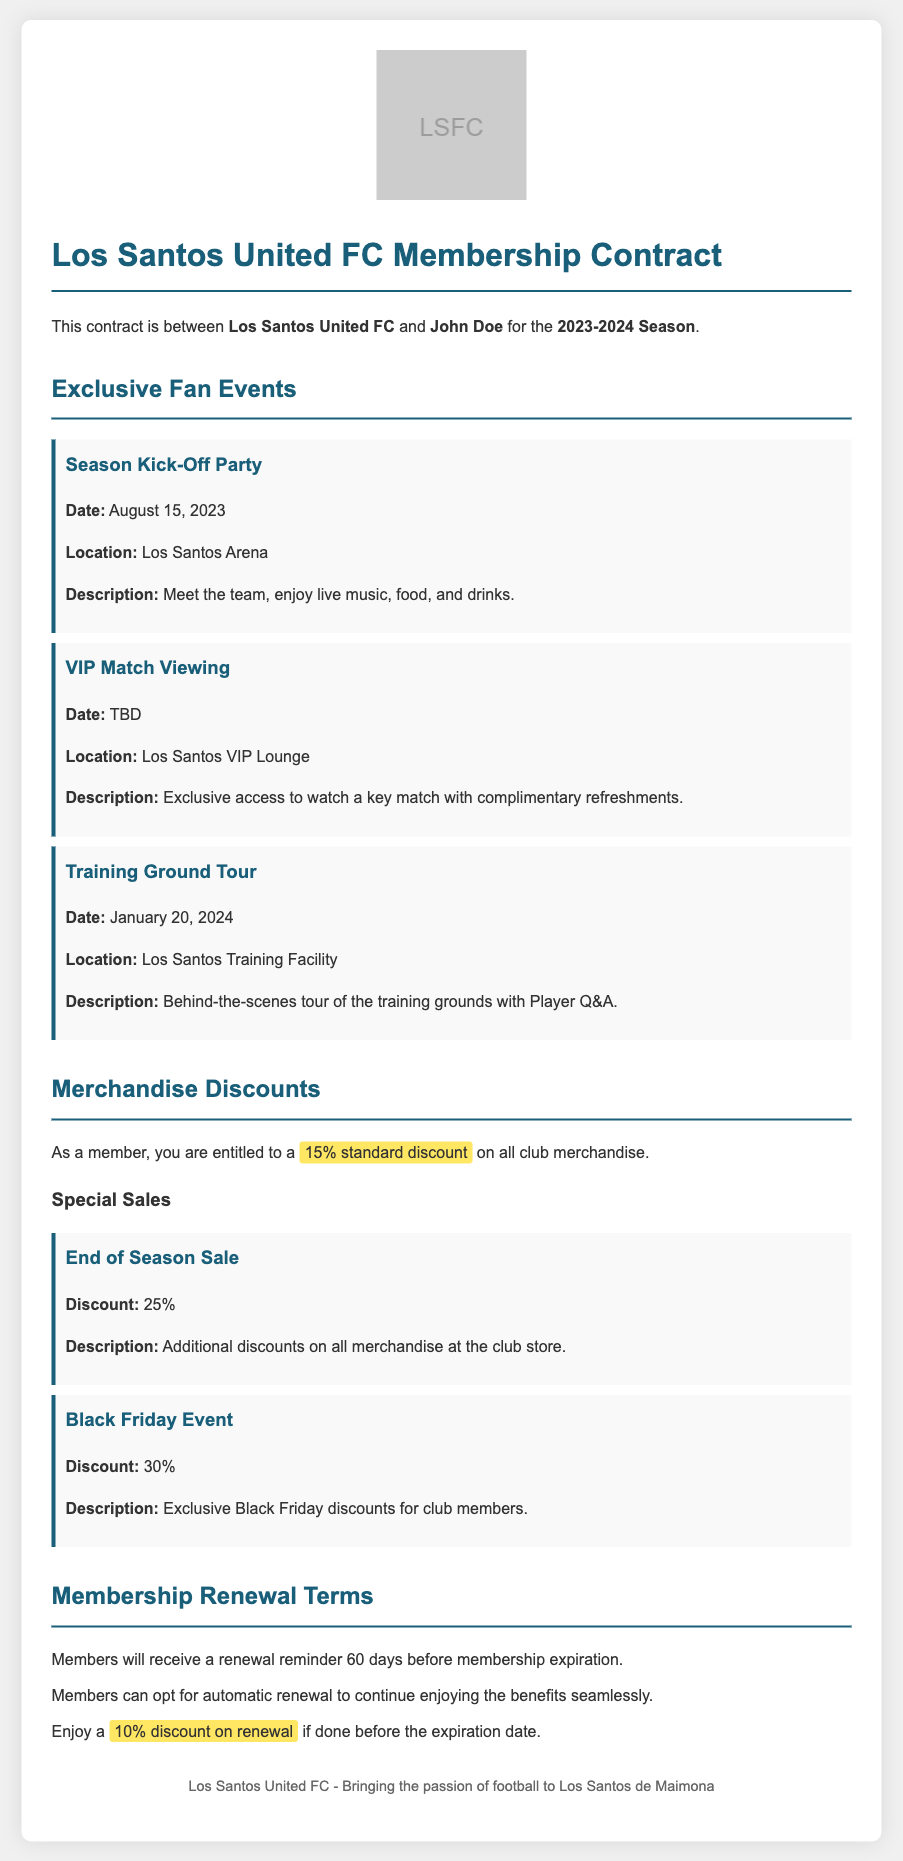What is the name of the football club? The name of the football club is mentioned at the beginning of the document as "Los Santos United FC."
Answer: Los Santos United FC What is the date of the Season Kick-Off Party? The event section lists the date for the Season Kick-Off Party as August 15, 2023.
Answer: August 15, 2023 What is the standard discount on club merchandise for members? The document specifies that members are entitled to a 15% standard discount on all club merchandise.
Answer: 15% How much discount is provided during the End of Season Sale? The End of Season Sale section mentions a discount of 25% on merchandise.
Answer: 25% When is the Training Ground Tour scheduled? The Training Ground Tour date is given as January 20, 2024, in the events section.
Answer: January 20, 2024 What benefit do members receive if they renew before expiration? The membership renewal terms state that members enjoy a 10% discount on renewal if done before the expiration date.
Answer: 10% discount How many days before expiration will members receive a renewal reminder? The contract states that members will receive a renewal reminder 60 days before membership expiration.
Answer: 60 days What must members do to opt for seamless renewal? The membership renewal terms indicate that members can opt for automatic renewal to continue enjoying benefits.
Answer: Automatic renewal What is the location for the VIP Match Viewing event? The document specifies that the VIP Match Viewing event takes place at the Los Santos VIP Lounge.
Answer: Los Santos VIP Lounge 